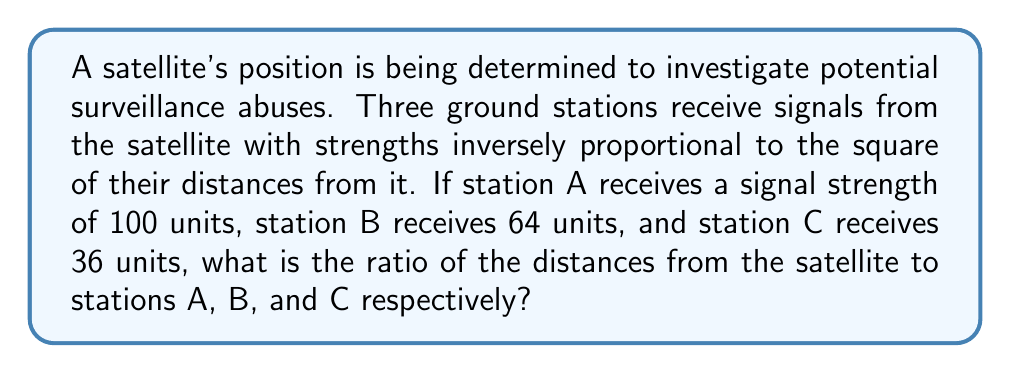Can you answer this question? To solve this problem, we need to use the inverse square law for signal strength. Let's approach this step-by-step:

1) Let the distances from the satellite to stations A, B, and C be $d_A$, $d_B$, and $d_C$ respectively.

2) According to the inverse square law, the signal strength $S$ is proportional to $\frac{1}{d^2}$, where $d$ is the distance. We can write this as:

   $S \propto \frac{1}{d^2}$ or $S = k \cdot \frac{1}{d^2}$, where $k$ is a constant.

3) For station A: $100 = k \cdot \frac{1}{d_A^2}$
   For station B: $64 = k \cdot \frac{1}{d_B^2}$
   For station C: $36 = k \cdot \frac{1}{d_C^2}$

4) We can eliminate $k$ by taking ratios:

   $\frac{100}{64} = \frac{d_B^2}{d_A^2}$ and $\frac{100}{36} = \frac{d_C^2}{d_A^2}$

5) Simplifying:

   $\frac{25}{16} = \left(\frac{d_B}{d_A}\right)^2$ and $\frac{25}{9} = \left(\frac{d_C}{d_A}\right)^2$

6) Taking the square root of both sides:

   $\frac{5}{4} = \frac{d_B}{d_A}$ and $\frac{5}{3} = \frac{d_C}{d_A}$

7) Therefore, the ratio $d_A : d_B : d_C$ is $1 : \frac{5}{4} : \frac{5}{3}$

8) To simplify this ratio, we can multiply all terms by 12:

   $d_A : d_B : d_C = 12 : 15 : 20$

This ratio represents the relative distances from the satellite to each ground station.
Answer: 12 : 15 : 20 